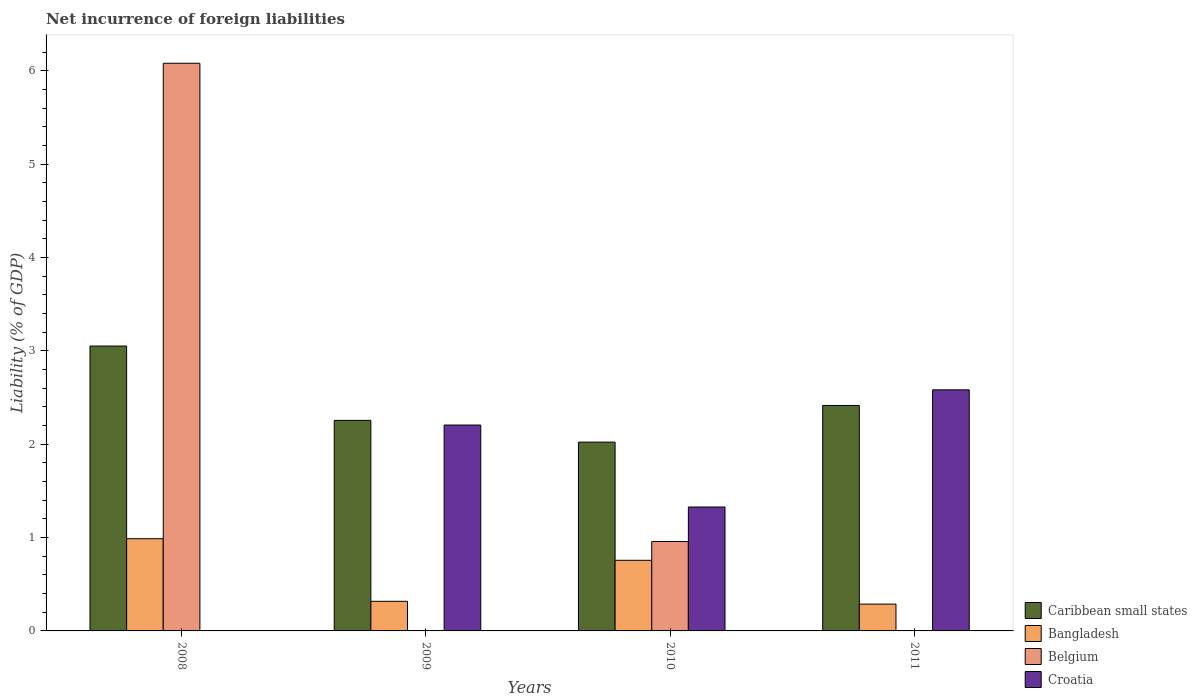How many different coloured bars are there?
Make the answer very short. 4. Are the number of bars per tick equal to the number of legend labels?
Your answer should be compact. No. Are the number of bars on each tick of the X-axis equal?
Keep it short and to the point. No. How many bars are there on the 1st tick from the right?
Your response must be concise. 3. Across all years, what is the maximum net incurrence of foreign liabilities in Bangladesh?
Ensure brevity in your answer.  0.99. What is the total net incurrence of foreign liabilities in Belgium in the graph?
Your answer should be very brief. 7.04. What is the difference between the net incurrence of foreign liabilities in Croatia in 2010 and that in 2011?
Keep it short and to the point. -1.26. What is the difference between the net incurrence of foreign liabilities in Croatia in 2008 and the net incurrence of foreign liabilities in Caribbean small states in 2011?
Your response must be concise. -2.42. What is the average net incurrence of foreign liabilities in Bangladesh per year?
Your response must be concise. 0.59. In the year 2010, what is the difference between the net incurrence of foreign liabilities in Belgium and net incurrence of foreign liabilities in Bangladesh?
Your response must be concise. 0.2. What is the ratio of the net incurrence of foreign liabilities in Bangladesh in 2009 to that in 2011?
Your answer should be very brief. 1.1. Is the net incurrence of foreign liabilities in Bangladesh in 2008 less than that in 2010?
Provide a short and direct response. No. What is the difference between the highest and the second highest net incurrence of foreign liabilities in Croatia?
Ensure brevity in your answer.  0.38. What is the difference between the highest and the lowest net incurrence of foreign liabilities in Caribbean small states?
Your response must be concise. 1.03. In how many years, is the net incurrence of foreign liabilities in Caribbean small states greater than the average net incurrence of foreign liabilities in Caribbean small states taken over all years?
Provide a short and direct response. 1. Is the sum of the net incurrence of foreign liabilities in Caribbean small states in 2008 and 2009 greater than the maximum net incurrence of foreign liabilities in Belgium across all years?
Offer a very short reply. No. Is it the case that in every year, the sum of the net incurrence of foreign liabilities in Caribbean small states and net incurrence of foreign liabilities in Belgium is greater than the net incurrence of foreign liabilities in Croatia?
Keep it short and to the point. No. Are all the bars in the graph horizontal?
Your answer should be very brief. No. How many years are there in the graph?
Your response must be concise. 4. What is the difference between two consecutive major ticks on the Y-axis?
Provide a succinct answer. 1. Are the values on the major ticks of Y-axis written in scientific E-notation?
Offer a very short reply. No. Does the graph contain grids?
Your answer should be compact. No. Where does the legend appear in the graph?
Your response must be concise. Bottom right. How many legend labels are there?
Keep it short and to the point. 4. What is the title of the graph?
Offer a very short reply. Net incurrence of foreign liabilities. Does "Maldives" appear as one of the legend labels in the graph?
Your response must be concise. No. What is the label or title of the X-axis?
Keep it short and to the point. Years. What is the label or title of the Y-axis?
Offer a very short reply. Liability (% of GDP). What is the Liability (% of GDP) of Caribbean small states in 2008?
Make the answer very short. 3.05. What is the Liability (% of GDP) of Bangladesh in 2008?
Provide a short and direct response. 0.99. What is the Liability (% of GDP) in Belgium in 2008?
Provide a succinct answer. 6.08. What is the Liability (% of GDP) of Caribbean small states in 2009?
Make the answer very short. 2.26. What is the Liability (% of GDP) in Bangladesh in 2009?
Make the answer very short. 0.32. What is the Liability (% of GDP) of Belgium in 2009?
Provide a short and direct response. 0. What is the Liability (% of GDP) in Croatia in 2009?
Your response must be concise. 2.21. What is the Liability (% of GDP) in Caribbean small states in 2010?
Provide a succinct answer. 2.02. What is the Liability (% of GDP) in Bangladesh in 2010?
Your answer should be compact. 0.76. What is the Liability (% of GDP) in Belgium in 2010?
Offer a very short reply. 0.96. What is the Liability (% of GDP) in Croatia in 2010?
Offer a terse response. 1.33. What is the Liability (% of GDP) of Caribbean small states in 2011?
Your answer should be compact. 2.42. What is the Liability (% of GDP) of Bangladesh in 2011?
Offer a terse response. 0.29. What is the Liability (% of GDP) of Croatia in 2011?
Your response must be concise. 2.58. Across all years, what is the maximum Liability (% of GDP) in Caribbean small states?
Ensure brevity in your answer.  3.05. Across all years, what is the maximum Liability (% of GDP) of Bangladesh?
Give a very brief answer. 0.99. Across all years, what is the maximum Liability (% of GDP) in Belgium?
Your answer should be very brief. 6.08. Across all years, what is the maximum Liability (% of GDP) in Croatia?
Make the answer very short. 2.58. Across all years, what is the minimum Liability (% of GDP) in Caribbean small states?
Make the answer very short. 2.02. Across all years, what is the minimum Liability (% of GDP) of Bangladesh?
Your answer should be very brief. 0.29. What is the total Liability (% of GDP) of Caribbean small states in the graph?
Ensure brevity in your answer.  9.75. What is the total Liability (% of GDP) of Bangladesh in the graph?
Your answer should be compact. 2.35. What is the total Liability (% of GDP) in Belgium in the graph?
Offer a terse response. 7.04. What is the total Liability (% of GDP) of Croatia in the graph?
Keep it short and to the point. 6.12. What is the difference between the Liability (% of GDP) in Caribbean small states in 2008 and that in 2009?
Your answer should be very brief. 0.8. What is the difference between the Liability (% of GDP) of Bangladesh in 2008 and that in 2009?
Your answer should be compact. 0.67. What is the difference between the Liability (% of GDP) in Caribbean small states in 2008 and that in 2010?
Ensure brevity in your answer.  1.03. What is the difference between the Liability (% of GDP) in Bangladesh in 2008 and that in 2010?
Make the answer very short. 0.23. What is the difference between the Liability (% of GDP) of Belgium in 2008 and that in 2010?
Make the answer very short. 5.12. What is the difference between the Liability (% of GDP) of Caribbean small states in 2008 and that in 2011?
Your response must be concise. 0.64. What is the difference between the Liability (% of GDP) in Bangladesh in 2008 and that in 2011?
Offer a terse response. 0.7. What is the difference between the Liability (% of GDP) in Caribbean small states in 2009 and that in 2010?
Offer a very short reply. 0.23. What is the difference between the Liability (% of GDP) in Bangladesh in 2009 and that in 2010?
Make the answer very short. -0.44. What is the difference between the Liability (% of GDP) in Croatia in 2009 and that in 2010?
Provide a short and direct response. 0.88. What is the difference between the Liability (% of GDP) in Caribbean small states in 2009 and that in 2011?
Offer a terse response. -0.16. What is the difference between the Liability (% of GDP) in Bangladesh in 2009 and that in 2011?
Provide a short and direct response. 0.03. What is the difference between the Liability (% of GDP) of Croatia in 2009 and that in 2011?
Offer a very short reply. -0.38. What is the difference between the Liability (% of GDP) of Caribbean small states in 2010 and that in 2011?
Provide a succinct answer. -0.39. What is the difference between the Liability (% of GDP) in Bangladesh in 2010 and that in 2011?
Provide a short and direct response. 0.47. What is the difference between the Liability (% of GDP) in Croatia in 2010 and that in 2011?
Offer a terse response. -1.26. What is the difference between the Liability (% of GDP) of Caribbean small states in 2008 and the Liability (% of GDP) of Bangladesh in 2009?
Provide a short and direct response. 2.74. What is the difference between the Liability (% of GDP) in Caribbean small states in 2008 and the Liability (% of GDP) in Croatia in 2009?
Provide a short and direct response. 0.85. What is the difference between the Liability (% of GDP) in Bangladesh in 2008 and the Liability (% of GDP) in Croatia in 2009?
Provide a succinct answer. -1.22. What is the difference between the Liability (% of GDP) in Belgium in 2008 and the Liability (% of GDP) in Croatia in 2009?
Give a very brief answer. 3.88. What is the difference between the Liability (% of GDP) of Caribbean small states in 2008 and the Liability (% of GDP) of Bangladesh in 2010?
Offer a very short reply. 2.3. What is the difference between the Liability (% of GDP) of Caribbean small states in 2008 and the Liability (% of GDP) of Belgium in 2010?
Your answer should be very brief. 2.09. What is the difference between the Liability (% of GDP) in Caribbean small states in 2008 and the Liability (% of GDP) in Croatia in 2010?
Your answer should be compact. 1.72. What is the difference between the Liability (% of GDP) in Bangladesh in 2008 and the Liability (% of GDP) in Belgium in 2010?
Your response must be concise. 0.03. What is the difference between the Liability (% of GDP) in Bangladesh in 2008 and the Liability (% of GDP) in Croatia in 2010?
Make the answer very short. -0.34. What is the difference between the Liability (% of GDP) of Belgium in 2008 and the Liability (% of GDP) of Croatia in 2010?
Offer a terse response. 4.75. What is the difference between the Liability (% of GDP) in Caribbean small states in 2008 and the Liability (% of GDP) in Bangladesh in 2011?
Provide a succinct answer. 2.77. What is the difference between the Liability (% of GDP) in Caribbean small states in 2008 and the Liability (% of GDP) in Croatia in 2011?
Your answer should be compact. 0.47. What is the difference between the Liability (% of GDP) in Bangladesh in 2008 and the Liability (% of GDP) in Croatia in 2011?
Offer a very short reply. -1.59. What is the difference between the Liability (% of GDP) of Belgium in 2008 and the Liability (% of GDP) of Croatia in 2011?
Ensure brevity in your answer.  3.5. What is the difference between the Liability (% of GDP) in Caribbean small states in 2009 and the Liability (% of GDP) in Bangladesh in 2010?
Your response must be concise. 1.5. What is the difference between the Liability (% of GDP) in Caribbean small states in 2009 and the Liability (% of GDP) in Belgium in 2010?
Make the answer very short. 1.3. What is the difference between the Liability (% of GDP) in Caribbean small states in 2009 and the Liability (% of GDP) in Croatia in 2010?
Provide a succinct answer. 0.93. What is the difference between the Liability (% of GDP) in Bangladesh in 2009 and the Liability (% of GDP) in Belgium in 2010?
Provide a succinct answer. -0.64. What is the difference between the Liability (% of GDP) in Bangladesh in 2009 and the Liability (% of GDP) in Croatia in 2010?
Your response must be concise. -1.01. What is the difference between the Liability (% of GDP) of Caribbean small states in 2009 and the Liability (% of GDP) of Bangladesh in 2011?
Provide a short and direct response. 1.97. What is the difference between the Liability (% of GDP) of Caribbean small states in 2009 and the Liability (% of GDP) of Croatia in 2011?
Offer a terse response. -0.33. What is the difference between the Liability (% of GDP) in Bangladesh in 2009 and the Liability (% of GDP) in Croatia in 2011?
Your response must be concise. -2.27. What is the difference between the Liability (% of GDP) in Caribbean small states in 2010 and the Liability (% of GDP) in Bangladesh in 2011?
Your response must be concise. 1.74. What is the difference between the Liability (% of GDP) in Caribbean small states in 2010 and the Liability (% of GDP) in Croatia in 2011?
Provide a succinct answer. -0.56. What is the difference between the Liability (% of GDP) in Bangladesh in 2010 and the Liability (% of GDP) in Croatia in 2011?
Your answer should be very brief. -1.83. What is the difference between the Liability (% of GDP) of Belgium in 2010 and the Liability (% of GDP) of Croatia in 2011?
Your answer should be compact. -1.63. What is the average Liability (% of GDP) of Caribbean small states per year?
Keep it short and to the point. 2.44. What is the average Liability (% of GDP) of Bangladesh per year?
Your answer should be compact. 0.59. What is the average Liability (% of GDP) in Belgium per year?
Offer a terse response. 1.76. What is the average Liability (% of GDP) in Croatia per year?
Provide a short and direct response. 1.53. In the year 2008, what is the difference between the Liability (% of GDP) in Caribbean small states and Liability (% of GDP) in Bangladesh?
Keep it short and to the point. 2.06. In the year 2008, what is the difference between the Liability (% of GDP) of Caribbean small states and Liability (% of GDP) of Belgium?
Provide a succinct answer. -3.03. In the year 2008, what is the difference between the Liability (% of GDP) of Bangladesh and Liability (% of GDP) of Belgium?
Ensure brevity in your answer.  -5.09. In the year 2009, what is the difference between the Liability (% of GDP) of Caribbean small states and Liability (% of GDP) of Bangladesh?
Provide a short and direct response. 1.94. In the year 2009, what is the difference between the Liability (% of GDP) in Caribbean small states and Liability (% of GDP) in Croatia?
Provide a short and direct response. 0.05. In the year 2009, what is the difference between the Liability (% of GDP) of Bangladesh and Liability (% of GDP) of Croatia?
Provide a succinct answer. -1.89. In the year 2010, what is the difference between the Liability (% of GDP) in Caribbean small states and Liability (% of GDP) in Bangladesh?
Make the answer very short. 1.27. In the year 2010, what is the difference between the Liability (% of GDP) in Caribbean small states and Liability (% of GDP) in Belgium?
Your answer should be compact. 1.07. In the year 2010, what is the difference between the Liability (% of GDP) in Caribbean small states and Liability (% of GDP) in Croatia?
Provide a succinct answer. 0.7. In the year 2010, what is the difference between the Liability (% of GDP) of Bangladesh and Liability (% of GDP) of Belgium?
Keep it short and to the point. -0.2. In the year 2010, what is the difference between the Liability (% of GDP) in Bangladesh and Liability (% of GDP) in Croatia?
Provide a succinct answer. -0.57. In the year 2010, what is the difference between the Liability (% of GDP) in Belgium and Liability (% of GDP) in Croatia?
Your answer should be compact. -0.37. In the year 2011, what is the difference between the Liability (% of GDP) in Caribbean small states and Liability (% of GDP) in Bangladesh?
Your answer should be very brief. 2.13. In the year 2011, what is the difference between the Liability (% of GDP) in Caribbean small states and Liability (% of GDP) in Croatia?
Ensure brevity in your answer.  -0.17. In the year 2011, what is the difference between the Liability (% of GDP) in Bangladesh and Liability (% of GDP) in Croatia?
Your answer should be compact. -2.3. What is the ratio of the Liability (% of GDP) of Caribbean small states in 2008 to that in 2009?
Your answer should be compact. 1.35. What is the ratio of the Liability (% of GDP) in Bangladesh in 2008 to that in 2009?
Your answer should be compact. 3.11. What is the ratio of the Liability (% of GDP) of Caribbean small states in 2008 to that in 2010?
Give a very brief answer. 1.51. What is the ratio of the Liability (% of GDP) of Bangladesh in 2008 to that in 2010?
Provide a succinct answer. 1.31. What is the ratio of the Liability (% of GDP) of Belgium in 2008 to that in 2010?
Offer a terse response. 6.35. What is the ratio of the Liability (% of GDP) in Caribbean small states in 2008 to that in 2011?
Provide a short and direct response. 1.26. What is the ratio of the Liability (% of GDP) of Bangladesh in 2008 to that in 2011?
Offer a terse response. 3.44. What is the ratio of the Liability (% of GDP) of Caribbean small states in 2009 to that in 2010?
Your answer should be compact. 1.12. What is the ratio of the Liability (% of GDP) in Bangladesh in 2009 to that in 2010?
Make the answer very short. 0.42. What is the ratio of the Liability (% of GDP) of Croatia in 2009 to that in 2010?
Your response must be concise. 1.66. What is the ratio of the Liability (% of GDP) of Caribbean small states in 2009 to that in 2011?
Your answer should be compact. 0.93. What is the ratio of the Liability (% of GDP) of Bangladesh in 2009 to that in 2011?
Keep it short and to the point. 1.1. What is the ratio of the Liability (% of GDP) in Croatia in 2009 to that in 2011?
Offer a very short reply. 0.85. What is the ratio of the Liability (% of GDP) in Caribbean small states in 2010 to that in 2011?
Keep it short and to the point. 0.84. What is the ratio of the Liability (% of GDP) in Bangladesh in 2010 to that in 2011?
Offer a very short reply. 2.63. What is the ratio of the Liability (% of GDP) of Croatia in 2010 to that in 2011?
Offer a very short reply. 0.51. What is the difference between the highest and the second highest Liability (% of GDP) of Caribbean small states?
Your answer should be very brief. 0.64. What is the difference between the highest and the second highest Liability (% of GDP) of Bangladesh?
Provide a short and direct response. 0.23. What is the difference between the highest and the second highest Liability (% of GDP) of Croatia?
Offer a very short reply. 0.38. What is the difference between the highest and the lowest Liability (% of GDP) of Caribbean small states?
Provide a succinct answer. 1.03. What is the difference between the highest and the lowest Liability (% of GDP) in Bangladesh?
Offer a terse response. 0.7. What is the difference between the highest and the lowest Liability (% of GDP) of Belgium?
Provide a short and direct response. 6.08. What is the difference between the highest and the lowest Liability (% of GDP) in Croatia?
Keep it short and to the point. 2.58. 